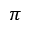<formula> <loc_0><loc_0><loc_500><loc_500>\pi</formula> 